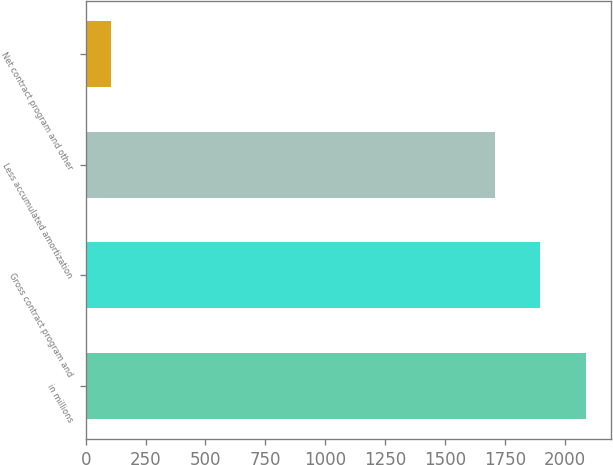Convert chart. <chart><loc_0><loc_0><loc_500><loc_500><bar_chart><fcel>in millions<fcel>Gross contract program and<fcel>Less accumulated amortization<fcel>Net contract program and other<nl><fcel>2089.8<fcel>1898.9<fcel>1708<fcel>104<nl></chart> 